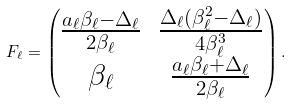Convert formula to latex. <formula><loc_0><loc_0><loc_500><loc_500>F _ { \ell } = \begin{pmatrix} \frac { a _ { \ell } \beta _ { \ell } - \Delta _ { \ell } } { 2 \beta _ { \ell } } & \frac { \Delta _ { \ell } ( \beta _ { \ell } ^ { 2 } - \Delta _ { \ell } ) } { 4 \beta _ { \ell } ^ { 3 } } \\ \beta _ { \ell } & \frac { a _ { \ell } \beta _ { \ell } + \Delta _ { \ell } } { 2 \beta _ { \ell } } \end{pmatrix} .</formula> 